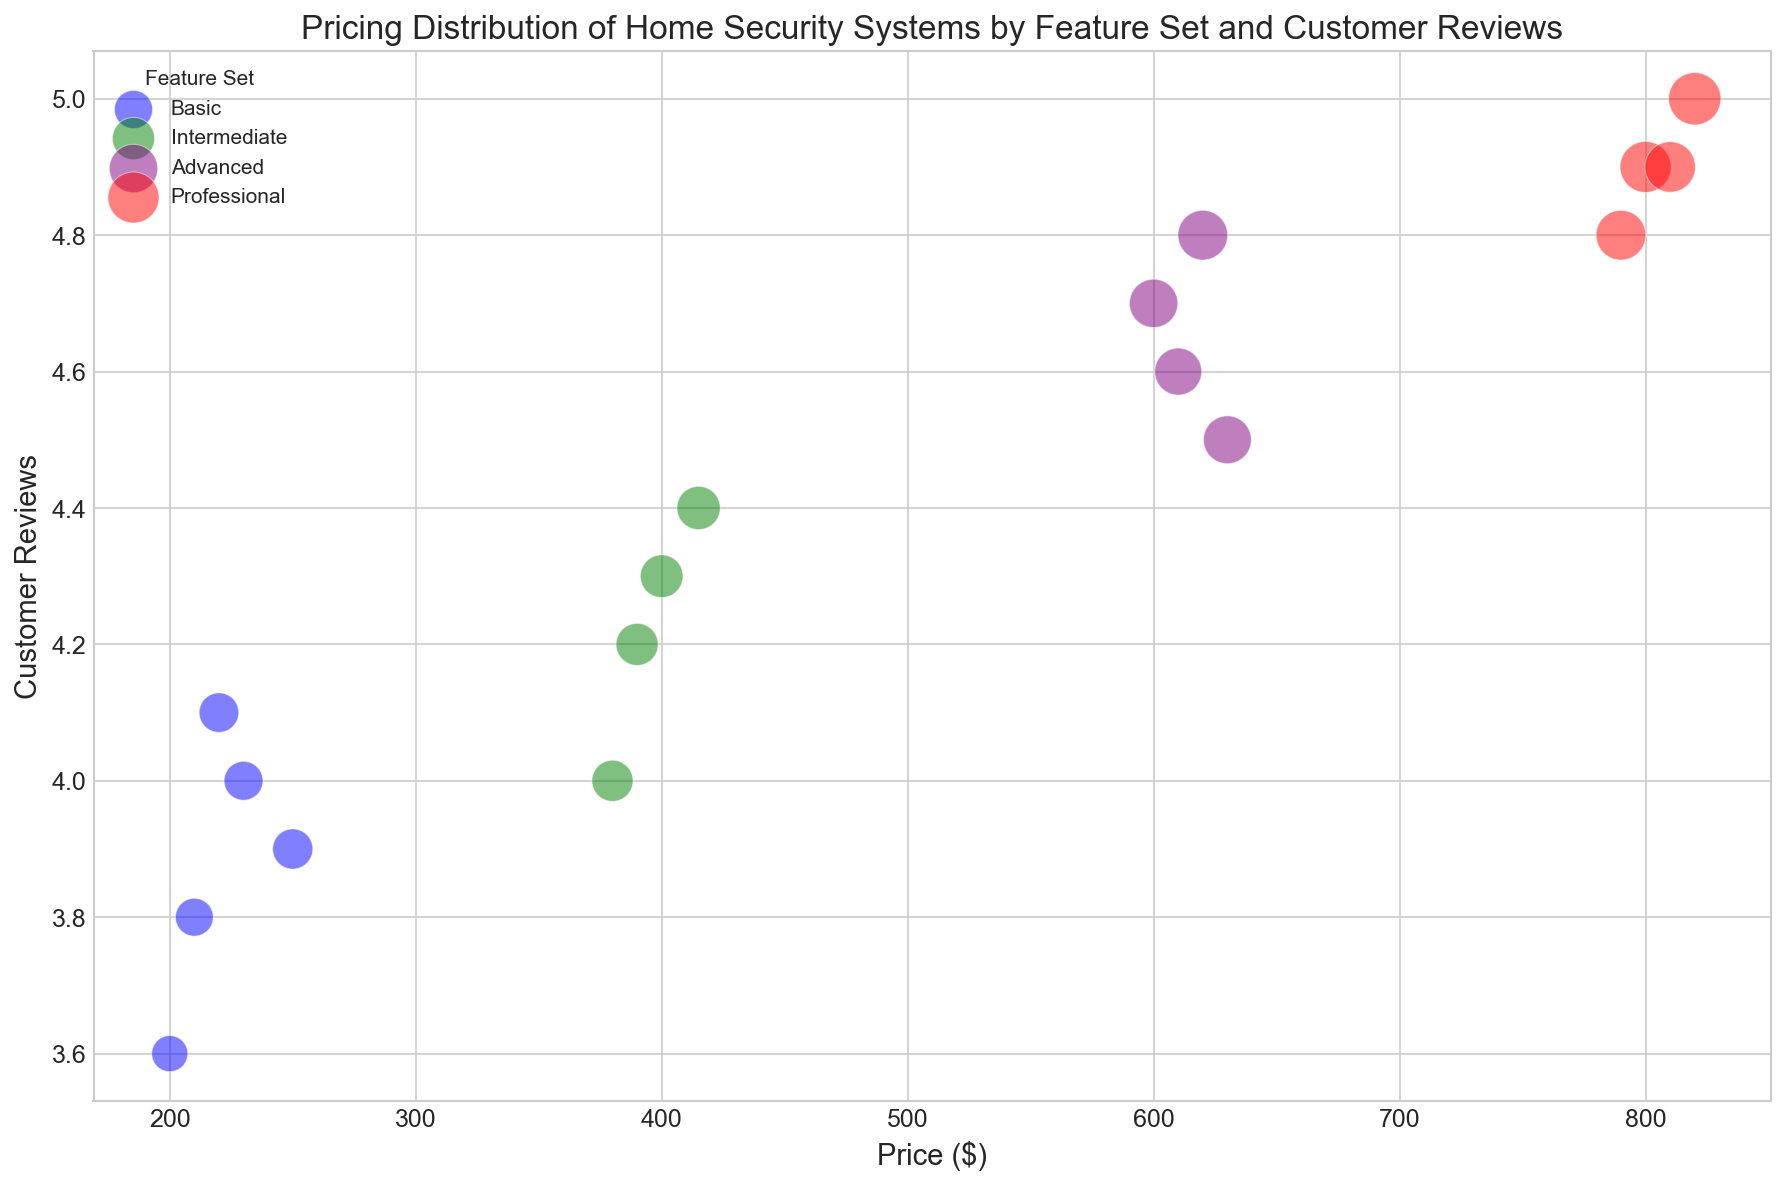What is the price range for the "Basic" feature set? By looking at the horizontal spread of bubbles colored in blue, identify the minimum and maximum price values along the x-axis.
Answer: $200 - $250 Which feature set has the highest average customer reviews? Calculate the average customer reviews for each feature set by summing up the reviews and dividing by the number of data points for that feature set. Compare the averages.
Answer: Professional Which feature set contains the largest bubble, and what does this indicate? Identify which color-coded bubbles have the largest size visually and check the corresponding feature set. The largest size indicates the highest represented "Size" value.
Answer: Professional, indicates highest size value of 105 How do the customer reviews for "Intermediate" feature sets compare to "Advanced"? Compare the vertical spread (y-axis) of green and purple bubbles. Identify which set encompasses higher average customer reviews and note the maximum values.
Answer: Advanced generally has higher customer reviews What is the price range for the "Professional" feature set? Analyze the spread of red bubbles from left to right along the x-axis to identify the minimum and maximum price values.
Answer: $790 - $820 For the "Advanced" feature set, what is the relationship between price and customer reviews? Look at the positioning of purple bubbles. Identify any patterns such as whether higher prices correspond to higher customer reviews.
Answer: Higher prices generally correspond to higher customer reviews What is the price difference between the highest priced "Basic" and "Intermediate" systems? Identify the highest prices for both the "Basic" (blue) and "Intermediate" (green) feature sets and calculate the difference.
Answer: $165 (415 - 250) Among the "Advanced" systems, which one has the lowest customer review and what is the corresponding price? Identify the purple bubble with the lowest y-value and read off the corresponding x-value.
Answer: $630, with a review of 4.5 What is the maximum size of bubbles in the "Basic" feature set compared to "Professional"? Identify the largest blue and red bubbles and compare their sizes.
Answer: 62 in Basic vs 105 in Professional 